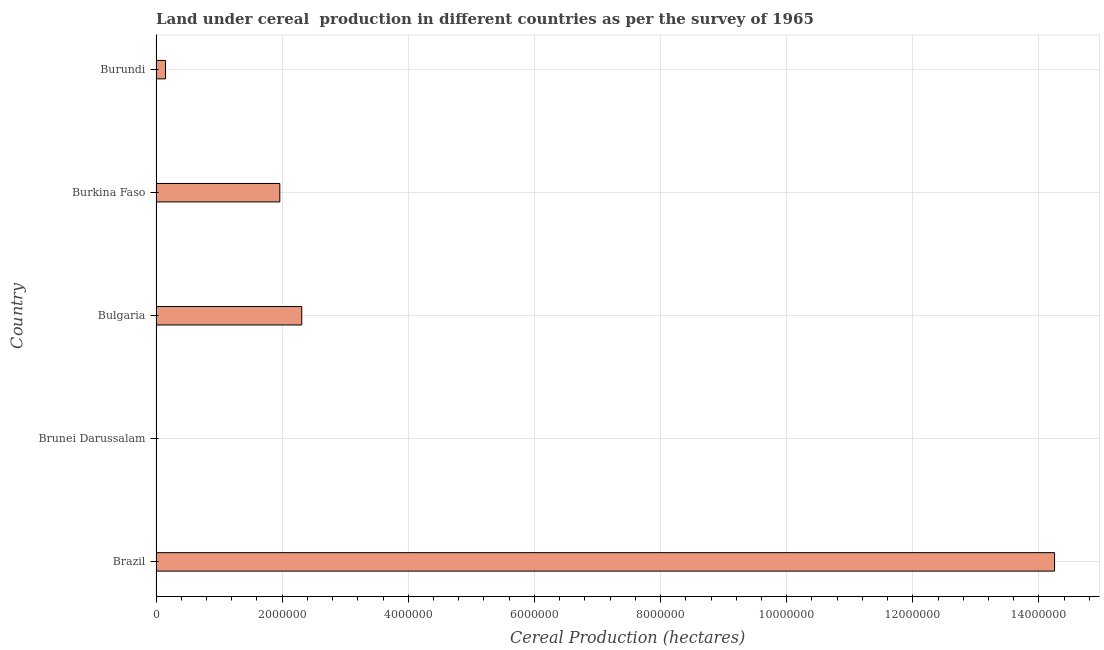What is the title of the graph?
Provide a short and direct response. Land under cereal  production in different countries as per the survey of 1965. What is the label or title of the X-axis?
Make the answer very short. Cereal Production (hectares). What is the label or title of the Y-axis?
Offer a terse response. Country. What is the land under cereal production in Burundi?
Provide a succinct answer. 1.51e+05. Across all countries, what is the maximum land under cereal production?
Make the answer very short. 1.42e+07. Across all countries, what is the minimum land under cereal production?
Your answer should be compact. 2510. In which country was the land under cereal production maximum?
Ensure brevity in your answer.  Brazil. In which country was the land under cereal production minimum?
Your answer should be compact. Brunei Darussalam. What is the sum of the land under cereal production?
Your response must be concise. 1.87e+07. What is the difference between the land under cereal production in Brunei Darussalam and Burundi?
Ensure brevity in your answer.  -1.48e+05. What is the average land under cereal production per country?
Make the answer very short. 3.73e+06. What is the median land under cereal production?
Your response must be concise. 1.96e+06. In how many countries, is the land under cereal production greater than 14000000 hectares?
Offer a very short reply. 1. What is the difference between the highest and the second highest land under cereal production?
Offer a terse response. 1.19e+07. What is the difference between the highest and the lowest land under cereal production?
Provide a succinct answer. 1.42e+07. In how many countries, is the land under cereal production greater than the average land under cereal production taken over all countries?
Provide a short and direct response. 1. How many bars are there?
Offer a terse response. 5. Are all the bars in the graph horizontal?
Ensure brevity in your answer.  Yes. How many countries are there in the graph?
Your answer should be compact. 5. Are the values on the major ticks of X-axis written in scientific E-notation?
Provide a short and direct response. No. What is the Cereal Production (hectares) in Brazil?
Give a very brief answer. 1.42e+07. What is the Cereal Production (hectares) in Brunei Darussalam?
Make the answer very short. 2510. What is the Cereal Production (hectares) of Bulgaria?
Provide a succinct answer. 2.31e+06. What is the Cereal Production (hectares) in Burkina Faso?
Offer a very short reply. 1.96e+06. What is the Cereal Production (hectares) in Burundi?
Offer a terse response. 1.51e+05. What is the difference between the Cereal Production (hectares) in Brazil and Brunei Darussalam?
Make the answer very short. 1.42e+07. What is the difference between the Cereal Production (hectares) in Brazil and Bulgaria?
Offer a very short reply. 1.19e+07. What is the difference between the Cereal Production (hectares) in Brazil and Burkina Faso?
Offer a very short reply. 1.23e+07. What is the difference between the Cereal Production (hectares) in Brazil and Burundi?
Provide a short and direct response. 1.41e+07. What is the difference between the Cereal Production (hectares) in Brunei Darussalam and Bulgaria?
Keep it short and to the point. -2.31e+06. What is the difference between the Cereal Production (hectares) in Brunei Darussalam and Burkina Faso?
Provide a short and direct response. -1.96e+06. What is the difference between the Cereal Production (hectares) in Brunei Darussalam and Burundi?
Your response must be concise. -1.48e+05. What is the difference between the Cereal Production (hectares) in Bulgaria and Burkina Faso?
Provide a succinct answer. 3.48e+05. What is the difference between the Cereal Production (hectares) in Bulgaria and Burundi?
Provide a succinct answer. 2.16e+06. What is the difference between the Cereal Production (hectares) in Burkina Faso and Burundi?
Your answer should be compact. 1.81e+06. What is the ratio of the Cereal Production (hectares) in Brazil to that in Brunei Darussalam?
Keep it short and to the point. 5676.47. What is the ratio of the Cereal Production (hectares) in Brazil to that in Bulgaria?
Offer a terse response. 6.17. What is the ratio of the Cereal Production (hectares) in Brazil to that in Burkina Faso?
Provide a succinct answer. 7.26. What is the ratio of the Cereal Production (hectares) in Brazil to that in Burundi?
Keep it short and to the point. 94.51. What is the ratio of the Cereal Production (hectares) in Brunei Darussalam to that in Bulgaria?
Make the answer very short. 0. What is the ratio of the Cereal Production (hectares) in Brunei Darussalam to that in Burkina Faso?
Your answer should be compact. 0. What is the ratio of the Cereal Production (hectares) in Brunei Darussalam to that in Burundi?
Your response must be concise. 0.02. What is the ratio of the Cereal Production (hectares) in Bulgaria to that in Burkina Faso?
Your answer should be compact. 1.18. What is the ratio of the Cereal Production (hectares) in Bulgaria to that in Burundi?
Give a very brief answer. 15.33. What is the ratio of the Cereal Production (hectares) in Burkina Faso to that in Burundi?
Give a very brief answer. 13.02. 